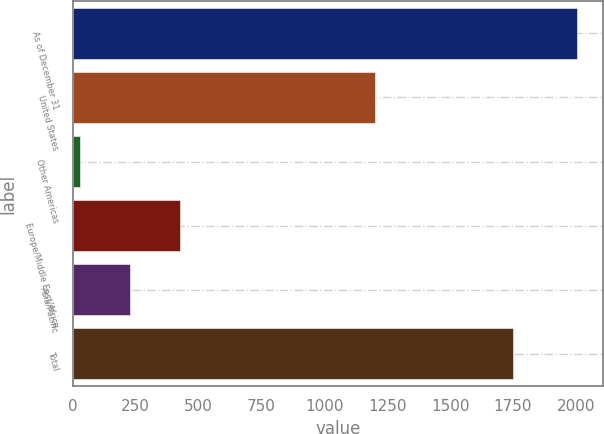Convert chart. <chart><loc_0><loc_0><loc_500><loc_500><bar_chart><fcel>As of December 31<fcel>United States<fcel>Other Americas<fcel>Europe/Middle East/Africa<fcel>Asia/Pacific<fcel>Total<nl><fcel>2006<fcel>1202<fcel>30<fcel>425.2<fcel>227.6<fcel>1749<nl></chart> 